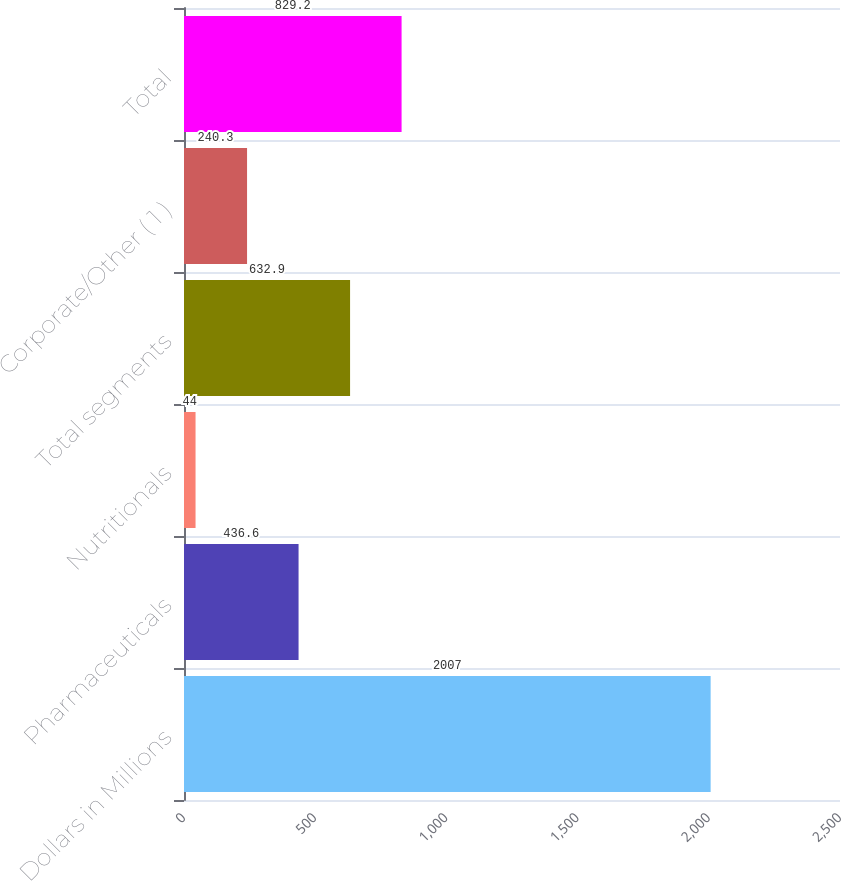Convert chart to OTSL. <chart><loc_0><loc_0><loc_500><loc_500><bar_chart><fcel>Dollars in Millions<fcel>Pharmaceuticals<fcel>Nutritionals<fcel>Total segments<fcel>Corporate/Other ( 1 )<fcel>Total<nl><fcel>2007<fcel>436.6<fcel>44<fcel>632.9<fcel>240.3<fcel>829.2<nl></chart> 